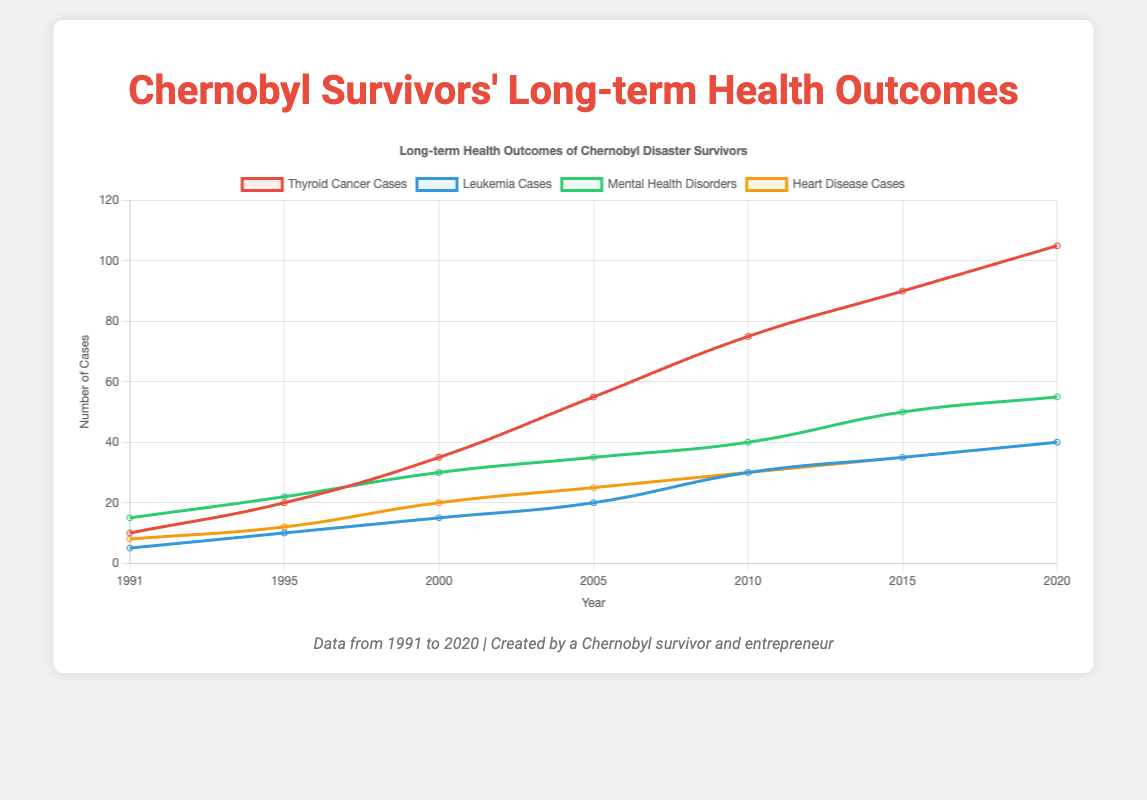What is the number of thyroid cancer cases in 2005? Look at the red line representing 'Thyroid Cancer Cases' and find the data point associated with the year 2005. The chart shows this value is 55.
Answer: 55 How did leukemia cases change from 2000 to 2010? Observe the blue line representing 'Leukemia Cases' between the years 2000 and 2010. The value increased from 15 in 2000 to 30 in 2010, indicating an increase of 15 cases.
Answer: Increased by 15 Which health issue had the highest number of cases in 2020? Examine the data points for all health issues in the year 2020. Thyroid cancer had the highest number of cases with 105, as represented by the highest red point.
Answer: Thyroid cancer What is the total number of mental health disorder cases reported from 1991 to 2020? Sum the mental health disorder cases for each year from 1991 to 2020: \(15 + 22 + 30 + 35 + 40 + 50 + 55 = 247\).
Answer: 247 Compare the heart disease cases in 1991 and 2015. Check the orange line representing 'Heart Disease Cases' for the years 1991 and 2015. In 1991, there were 8 cases, and in 2015, there were 35 cases. Heart disease cases increased by 27 from 1991 to 2015.
Answer: Increased by 27 What is the average number of leukemia cases over the years displayed? Add up all leukemia cases and divide by the number of years: \(\frac{5 + 10 + 15 + 20 + 30 + 35 + 40}{7} = \frac{155}{7} \approx 22.14\).
Answer: 22.14 Which year shows the biggest increase in thyroid cancer cases compared to the previous year? Calculate the annual increases for thyroid cancer: \(20-10 = 10\), \(35-20 = 15\), \(55-35 = 20\), \(75-55 = 20\), \(90-75 = 15\), \(105-90 = 15\). The biggest increase of 20 cases occurred from 2000 to 2005 and from 2005 to 2010.
Answer: 2000-2005 and 2005-2010 What's the average number of heart disease cases per year between 1995 and 2010? Sum the heart disease cases from 1995 to 2010 and divide by the number of years: \(\frac{12 + 20 + 25 + 30}{4} = \frac{87}{4} \approx 21.75\).
Answer: 21.75 During which period did mental health disorders increase the most rapidly? Analyze the increments of mental health disorder cases over the intervals: \(22-15 = 7\), \(30-22 = 8\), \(35-30 = 5\), \(40-35 = 5\), \(50-40 = 10\), \(55-50 = 5\). The most rapid increase of 10 cases occurred from 2010 to 2015.
Answer: 2010-2015 